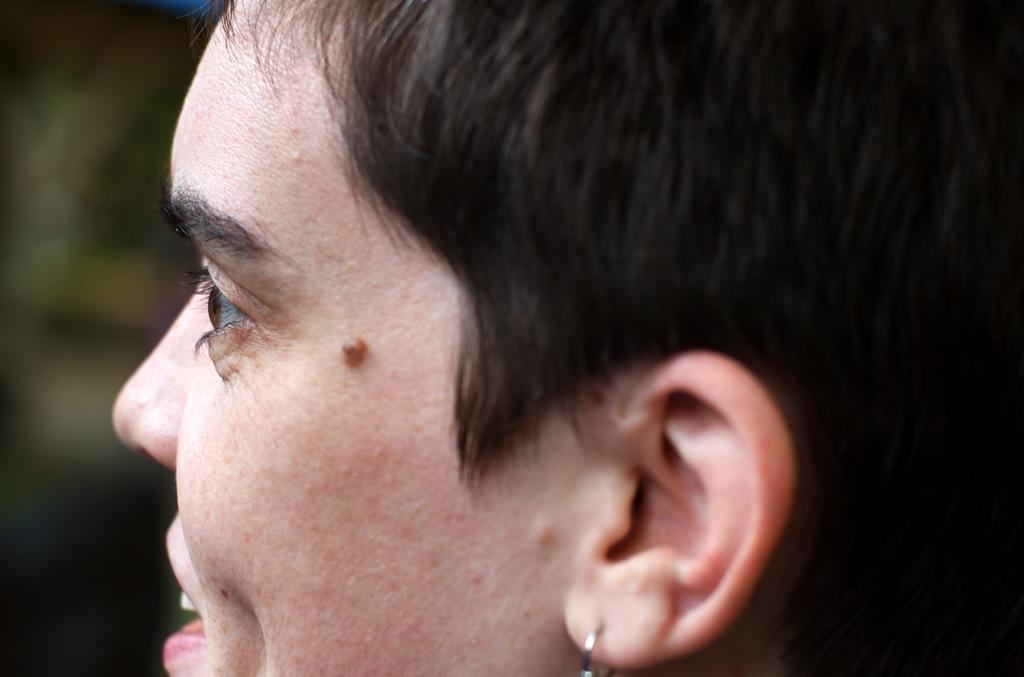What is the main subject of the image? There is a person in the image. Can you describe the background of the image? The background of the image is blurred. What is the person's annual income in the image? There is no information about the person's income in the image. How many spiders are crawling on the person in the image? There are no spiders present in the image. 